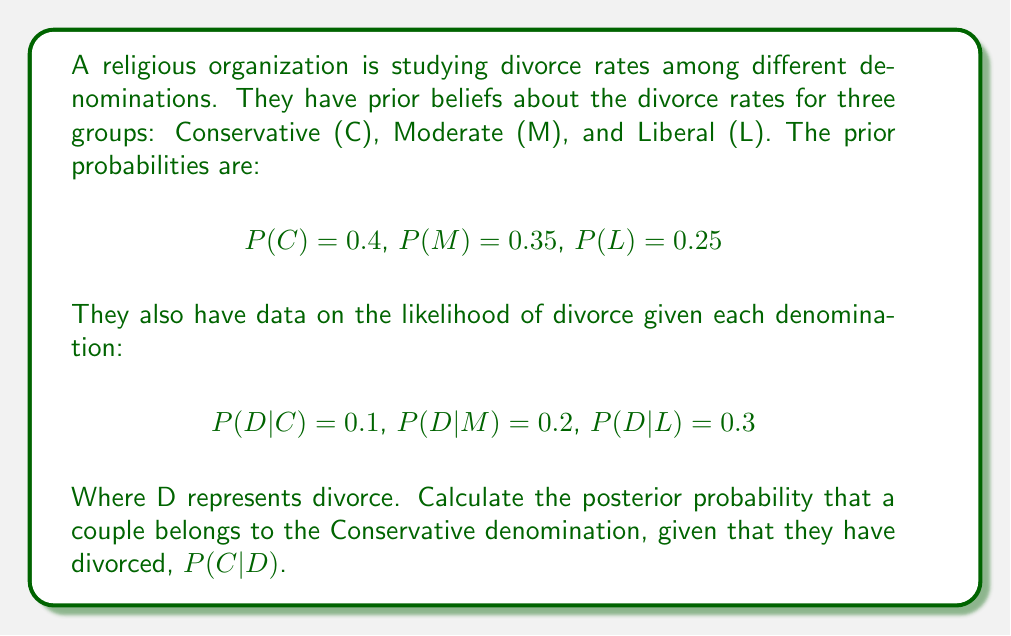Could you help me with this problem? To solve this problem, we'll use Bayes' Theorem:

$$P(C|D) = \frac{P(D|C) \cdot P(C)}{P(D)}$$

We have $P(D|C)$ and $P(C)$, but we need to calculate $P(D)$ using the law of total probability:

$$P(D) = P(D|C) \cdot P(C) + P(D|M) \cdot P(M) + P(D|L) \cdot P(L)$$

Let's calculate $P(D)$:

$$\begin{align}
P(D) &= 0.1 \cdot 0.4 + 0.2 \cdot 0.35 + 0.3 \cdot 0.25 \\
&= 0.04 + 0.07 + 0.075 \\
&= 0.185
\end{align}$$

Now we can apply Bayes' Theorem:

$$\begin{align}
P(C|D) &= \frac{P(D|C) \cdot P(C)}{P(D)} \\
&= \frac{0.1 \cdot 0.4}{0.185} \\
&= \frac{0.04}{0.185} \\
&\approx 0.2162
\end{align}$$
Answer: The posterior probability that a divorced couple belongs to the Conservative denomination is approximately 0.2162 or 21.62%. 